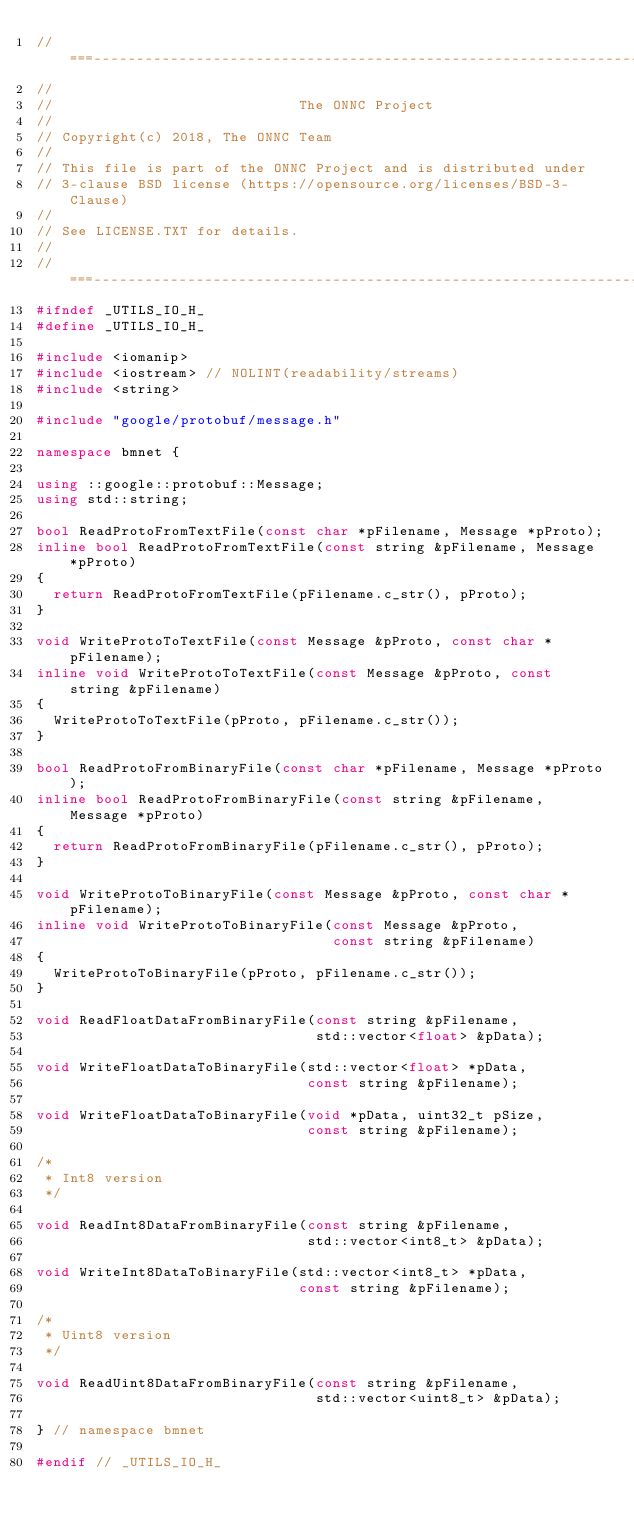<code> <loc_0><loc_0><loc_500><loc_500><_C++_>//===---------------------------------------------------------------------===//
//
//                             The ONNC Project
//
// Copyright(c) 2018, The ONNC Team
//
// This file is part of the ONNC Project and is distributed under
// 3-clause BSD license (https://opensource.org/licenses/BSD-3-Clause)
//
// See LICENSE.TXT for details.
//
//===---------------------------------------------------------------------===//
#ifndef _UTILS_IO_H_
#define _UTILS_IO_H_

#include <iomanip>
#include <iostream> // NOLINT(readability/streams)
#include <string>

#include "google/protobuf/message.h"

namespace bmnet {

using ::google::protobuf::Message;
using std::string;

bool ReadProtoFromTextFile(const char *pFilename, Message *pProto);
inline bool ReadProtoFromTextFile(const string &pFilename, Message *pProto)
{
  return ReadProtoFromTextFile(pFilename.c_str(), pProto);
}

void WriteProtoToTextFile(const Message &pProto, const char *pFilename);
inline void WriteProtoToTextFile(const Message &pProto, const string &pFilename)
{
  WriteProtoToTextFile(pProto, pFilename.c_str());
}

bool ReadProtoFromBinaryFile(const char *pFilename, Message *pProto);
inline bool ReadProtoFromBinaryFile(const string &pFilename, Message *pProto)
{
  return ReadProtoFromBinaryFile(pFilename.c_str(), pProto);
}

void WriteProtoToBinaryFile(const Message &pProto, const char *pFilename);
inline void WriteProtoToBinaryFile(const Message &pProto,
                                   const string &pFilename)
{
  WriteProtoToBinaryFile(pProto, pFilename.c_str());
}

void ReadFloatDataFromBinaryFile(const string &pFilename,
                                 std::vector<float> &pData);

void WriteFloatDataToBinaryFile(std::vector<float> *pData,
                                const string &pFilename);

void WriteFloatDataToBinaryFile(void *pData, uint32_t pSize,
                                const string &pFilename);

/*
 * Int8 version
 */

void ReadInt8DataFromBinaryFile(const string &pFilename,
                                std::vector<int8_t> &pData);

void WriteInt8DataToBinaryFile(std::vector<int8_t> *pData,
                               const string &pFilename);

/*
 * Uint8 version
 */

void ReadUint8DataFromBinaryFile(const string &pFilename,
                                 std::vector<uint8_t> &pData);

} // namespace bmnet

#endif // _UTILS_IO_H_
</code> 